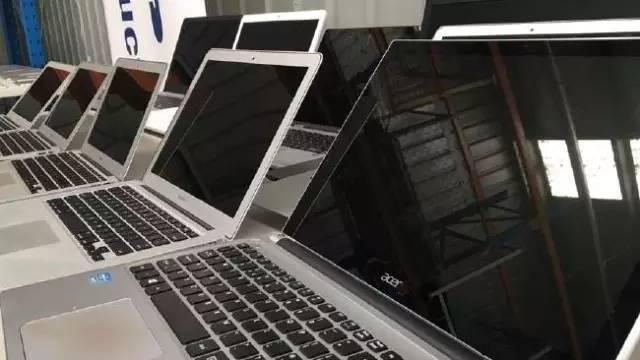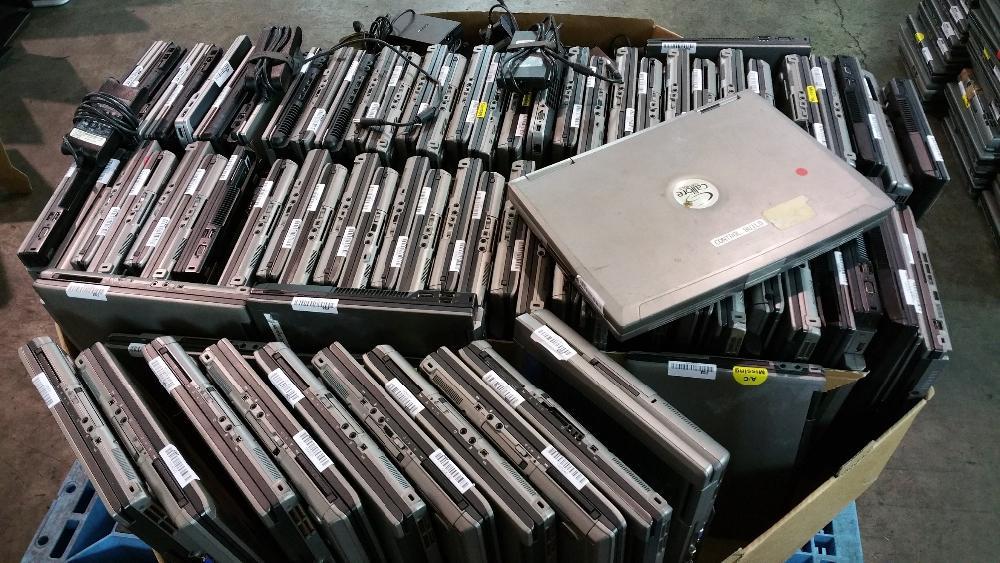The first image is the image on the left, the second image is the image on the right. For the images shown, is this caption "In the image to the left, the electronics are in boxes." true? Answer yes or no. No. The first image is the image on the left, the second image is the image on the right. For the images displayed, is the sentence "An image shows multiple laptops stored upright in a cardboard box without cardboard dividers between any laptops in the box." factually correct? Answer yes or no. Yes. 